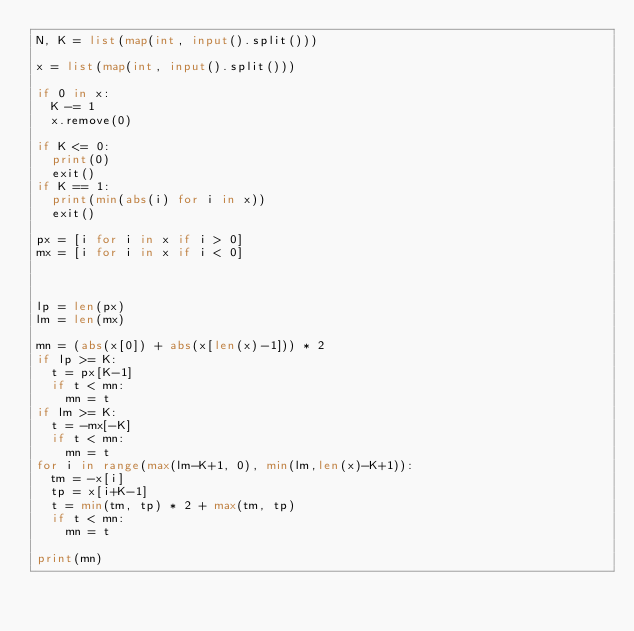<code> <loc_0><loc_0><loc_500><loc_500><_Python_>N, K = list(map(int, input().split()))

x = list(map(int, input().split()))

if 0 in x:
  K -= 1
  x.remove(0)
  
if K <= 0:
  print(0)
  exit()
if K == 1:
  print(min(abs(i) for i in x))
  exit()
  
px = [i for i in x if i > 0]
mx = [i for i in x if i < 0]


  
lp = len(px)
lm = len(mx)

mn = (abs(x[0]) + abs(x[len(x)-1])) * 2
if lp >= K:
  t = px[K-1]
  if t < mn:
    mn = t
if lm >= K:
  t = -mx[-K]
  if t < mn:
    mn = t
for i in range(max(lm-K+1, 0), min(lm,len(x)-K+1)):
  tm = -x[i]
  tp = x[i+K-1]
  t = min(tm, tp) * 2 + max(tm, tp)
  if t < mn:
    mn = t
  
print(mn)</code> 